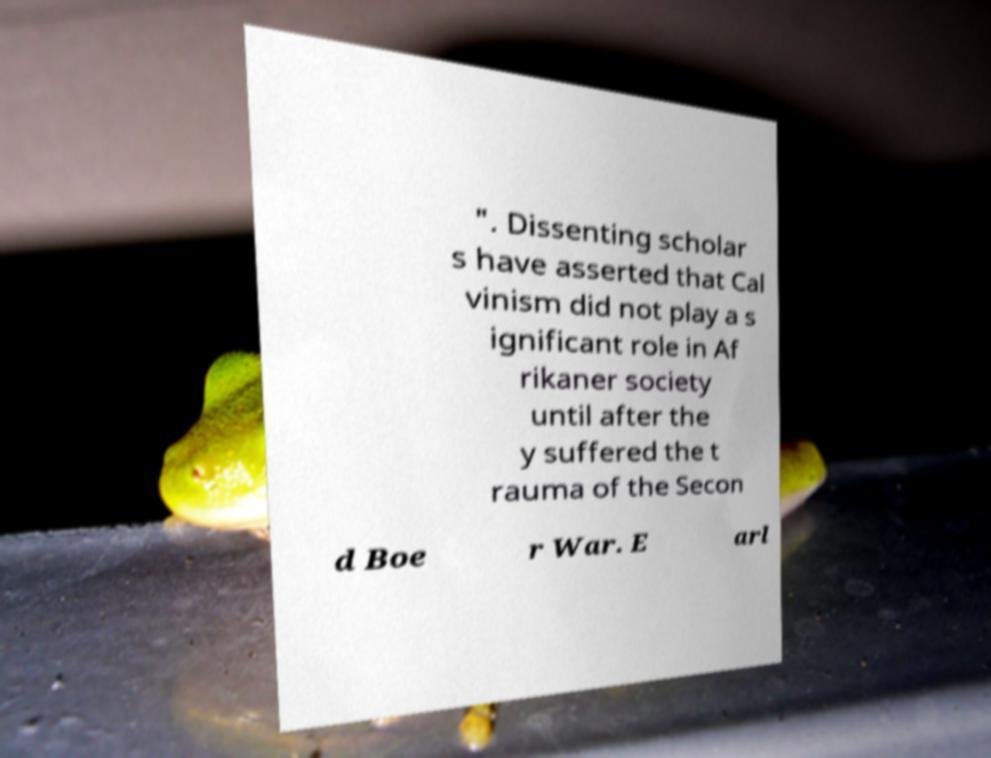Could you assist in decoding the text presented in this image and type it out clearly? ". Dissenting scholar s have asserted that Cal vinism did not play a s ignificant role in Af rikaner society until after the y suffered the t rauma of the Secon d Boe r War. E arl 